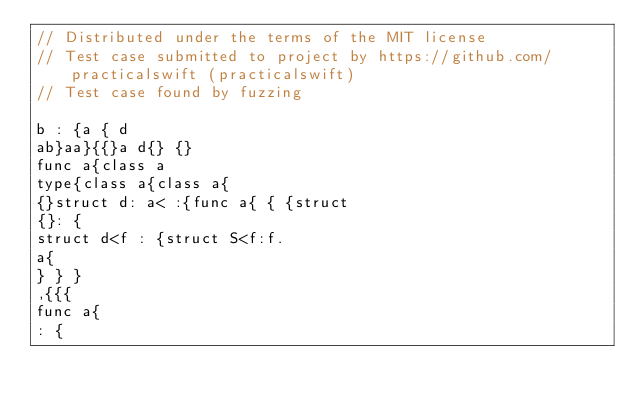<code> <loc_0><loc_0><loc_500><loc_500><_Swift_>// Distributed under the terms of the MIT license
// Test case submitted to project by https://github.com/practicalswift (practicalswift)
// Test case found by fuzzing

b : {a { d
ab}aa}{{}a d{} {}
func a{class a
type{class a{class a{
{}struct d: a< :{func a{ { {struct
{}: {
struct d<f : {struct S<f:f.
a{
} } }
,{{{
func a{
: {
</code> 